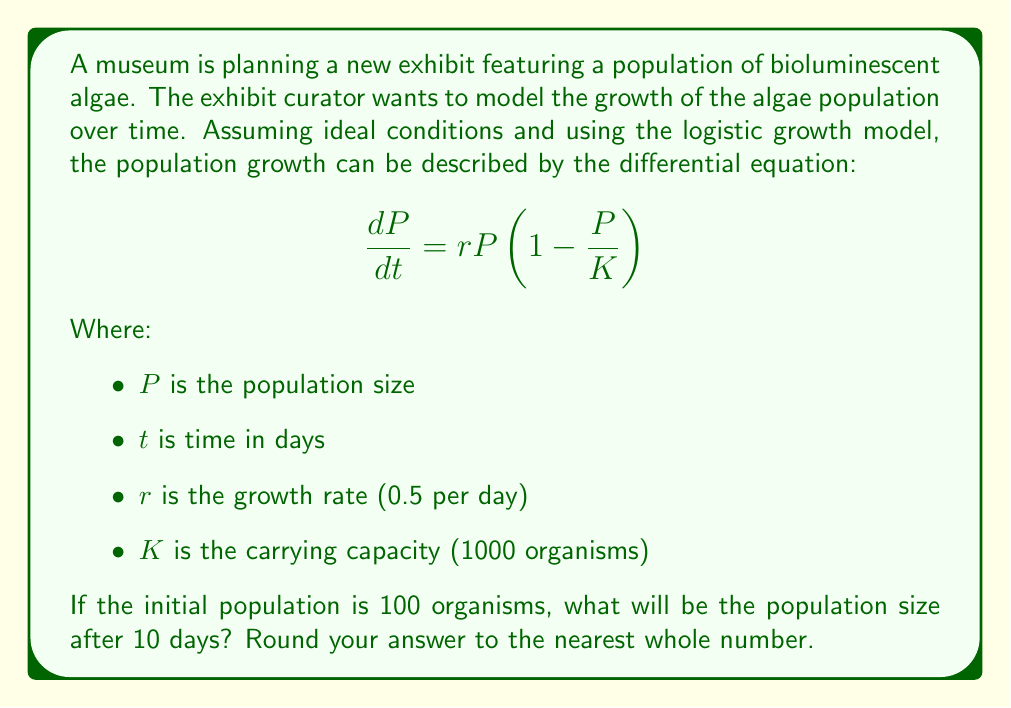What is the answer to this math problem? To solve this problem, we need to use the solution to the logistic growth differential equation:

$$P(t) = \frac{K}{1 + (\frac{K}{P_0} - 1)e^{-rt}}$$

Where:
$P(t)$ is the population size at time $t$
$P_0$ is the initial population size
$K$ is the carrying capacity
$r$ is the growth rate
$t$ is time

Let's substitute the given values:
$K = 1000$
$P_0 = 100$
$r = 0.5$
$t = 10$

$$P(10) = \frac{1000}{1 + (\frac{1000}{100} - 1)e^{-0.5 \cdot 10}}$$

$$= \frac{1000}{1 + 9e^{-5}}$$

$$= \frac{1000}{1 + 9 \cdot 0.00674}$$

$$= \frac{1000}{1 + 0.06066}$$

$$= \frac{1000}{1.06066}$$

$$\approx 942.82$$

Rounding to the nearest whole number, we get 943.
Answer: 943 organisms 